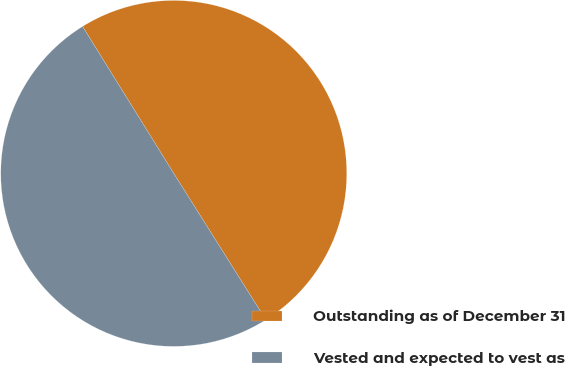Convert chart. <chart><loc_0><loc_0><loc_500><loc_500><pie_chart><fcel>Outstanding as of December 31<fcel>Vested and expected to vest as<nl><fcel>49.9%<fcel>50.1%<nl></chart> 